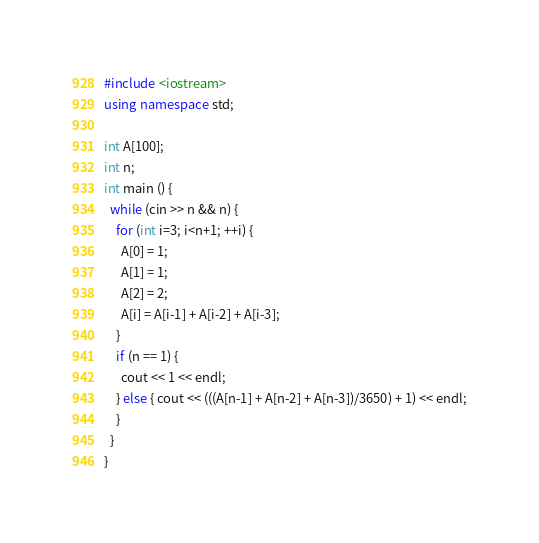Convert code to text. <code><loc_0><loc_0><loc_500><loc_500><_C++_>#include <iostream>
using namespace std;

int A[100];
int n;
int main () {
  while (cin >> n && n) {
    for (int i=3; i<n+1; ++i) {
      A[0] = 1;
      A[1] = 1;
      A[2] = 2;
      A[i] = A[i-1] + A[i-2] + A[i-3];
    }
    if (n == 1) {
      cout << 1 << endl;
    } else { cout << (((A[n-1] + A[n-2] + A[n-3])/3650) + 1) << endl;
    }
  }
}</code> 